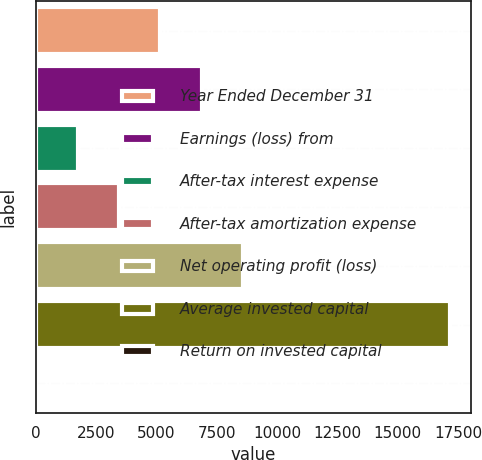<chart> <loc_0><loc_0><loc_500><loc_500><bar_chart><fcel>Year Ended December 31<fcel>Earnings (loss) from<fcel>After-tax interest expense<fcel>After-tax amortization expense<fcel>Net operating profit (loss)<fcel>Average invested capital<fcel>Return on invested capital<nl><fcel>5161.88<fcel>6877.04<fcel>1731.56<fcel>3446.72<fcel>8592.2<fcel>17168<fcel>16.4<nl></chart> 